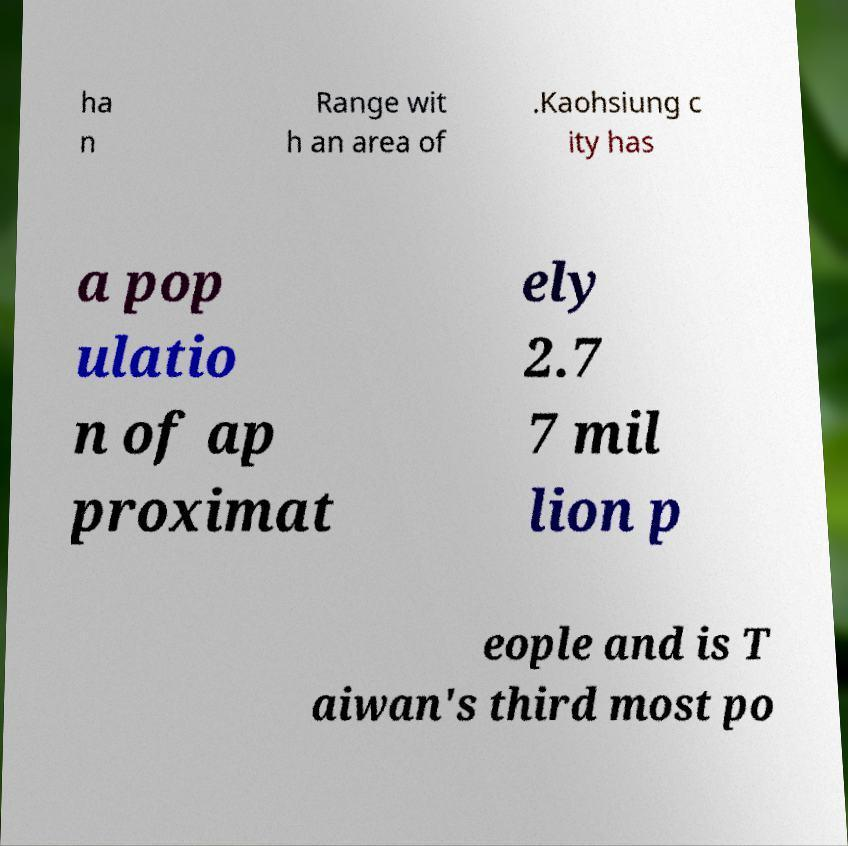What messages or text are displayed in this image? I need them in a readable, typed format. ha n Range wit h an area of .Kaohsiung c ity has a pop ulatio n of ap proximat ely 2.7 7 mil lion p eople and is T aiwan's third most po 